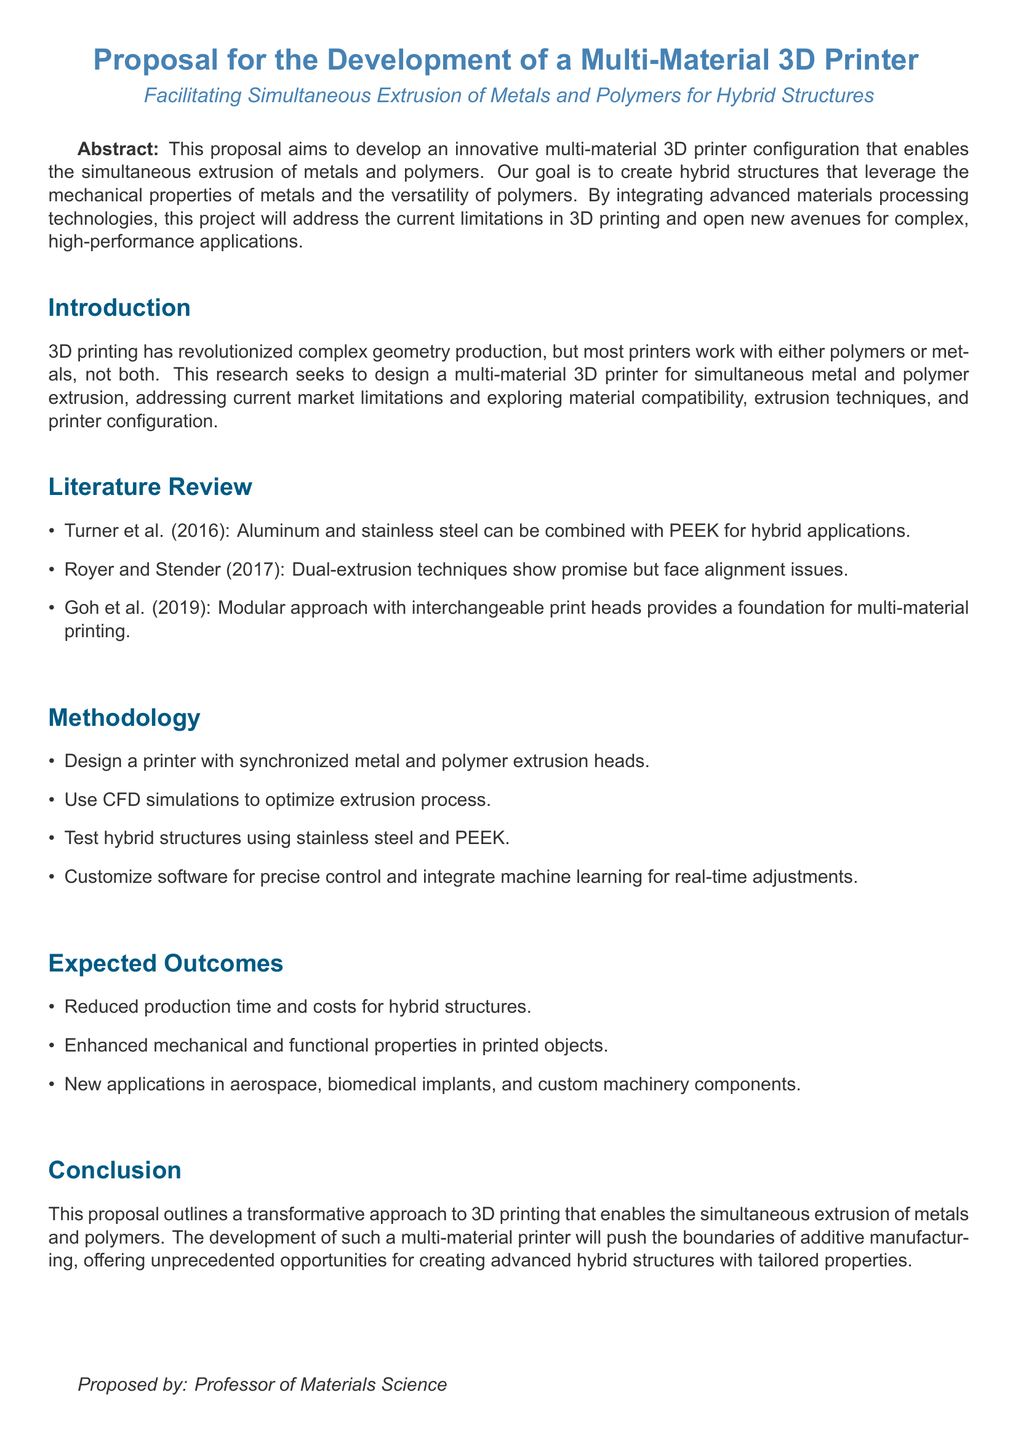What is the aim of the proposal? The aim of the proposal is to develop an innovative multi-material 3D printer configuration that enables the simultaneous extrusion of metals and polymers.
Answer: To develop an innovative multi-material 3D printer configuration Who are the authors referenced in the literature review? The authors referenced in the literature review are Turner, Royer, Stender, and Goh.
Answer: Turner et al., Royer and Stender, Goh et al Which materials are tested for hybrid structures? The materials tested for hybrid structures are stainless steel and PEEK.
Answer: Stainless steel and PEEK What is expected to be enhanced in printed objects? The expected enhancement in printed objects is their mechanical and functional properties.
Answer: Mechanical and functional properties What approach does Goh et al. (2019) suggest for multi-material printing? Goh et al. (2019) suggest a modular approach with interchangeable print heads.
Answer: Modular approach with interchangeable print heads What technology is customized for precise control of the printing process? The technology customized for precise control of the printing process is software.
Answer: Software What is one of the new applications mentioned in the expected outcomes? One of the new applications mentioned in the expected outcomes is aerospace.
Answer: Aerospace What are the anticipated benefits of reduced production time? The anticipated benefits of reduced production time are reduced costs for hybrid structures.
Answer: Reduced costs for hybrid structures 